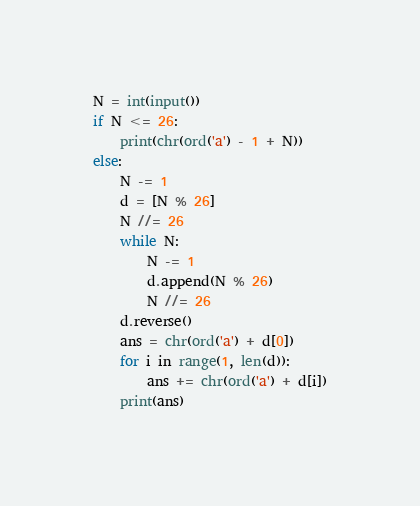Convert code to text. <code><loc_0><loc_0><loc_500><loc_500><_Python_>N = int(input())
if N <= 26:
    print(chr(ord('a') - 1 + N))
else:
    N -= 1
    d = [N % 26]
    N //= 26
    while N:
        N -= 1
        d.append(N % 26)
        N //= 26
    d.reverse()
    ans = chr(ord('a') + d[0])
    for i in range(1, len(d)):
        ans += chr(ord('a') + d[i])
    print(ans)
</code> 